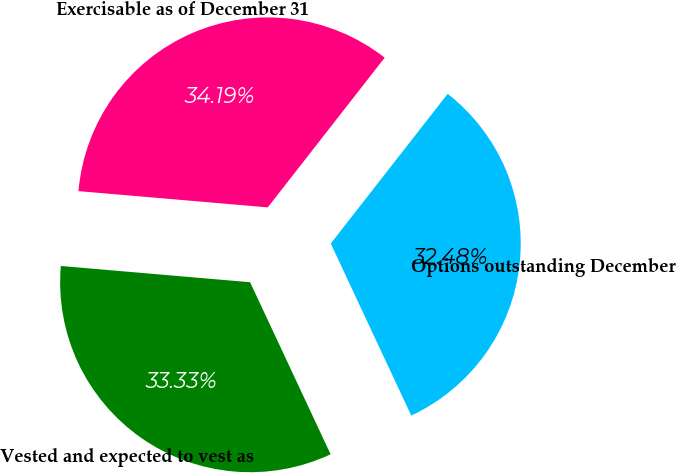Convert chart to OTSL. <chart><loc_0><loc_0><loc_500><loc_500><pie_chart><fcel>Options outstanding December<fcel>Vested and expected to vest as<fcel>Exercisable as of December 31<nl><fcel>32.48%<fcel>33.33%<fcel>34.19%<nl></chart> 